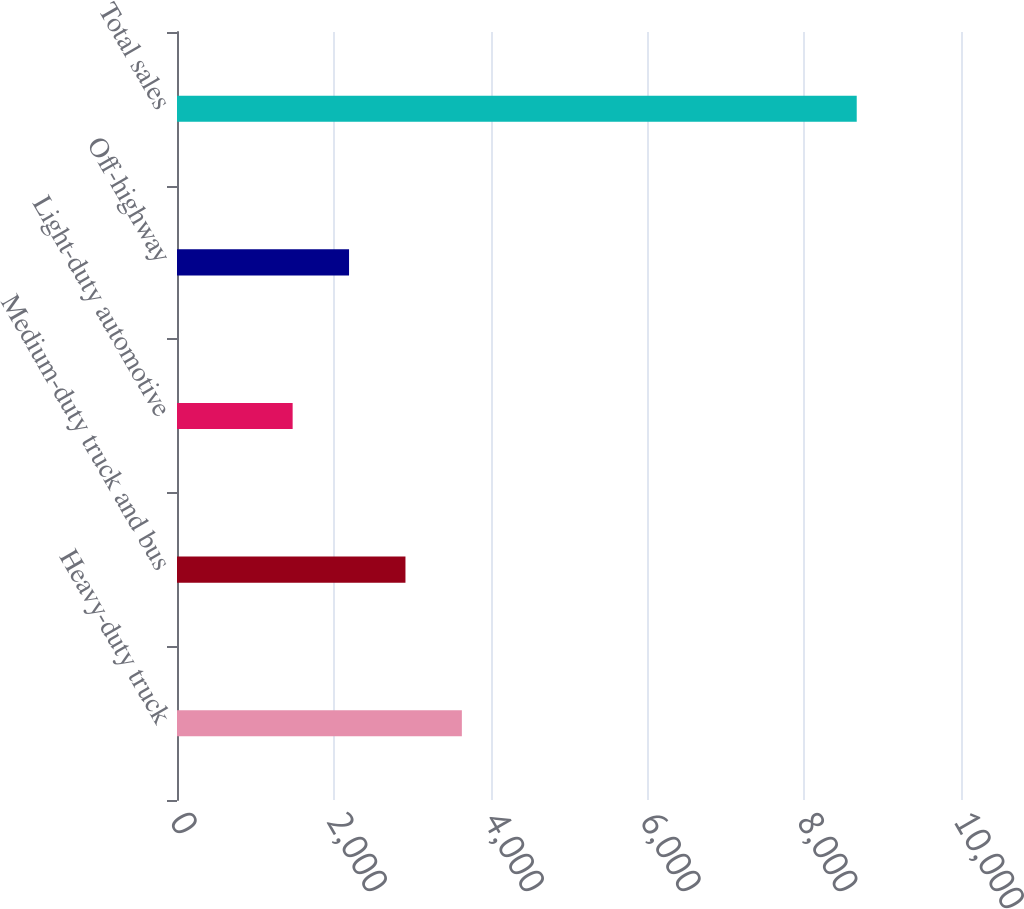Convert chart to OTSL. <chart><loc_0><loc_0><loc_500><loc_500><bar_chart><fcel>Heavy-duty truck<fcel>Medium-duty truck and bus<fcel>Light-duty automotive<fcel>Off-highway<fcel>Total sales<nl><fcel>3633.5<fcel>2914<fcel>1475<fcel>2194.5<fcel>8670<nl></chart> 